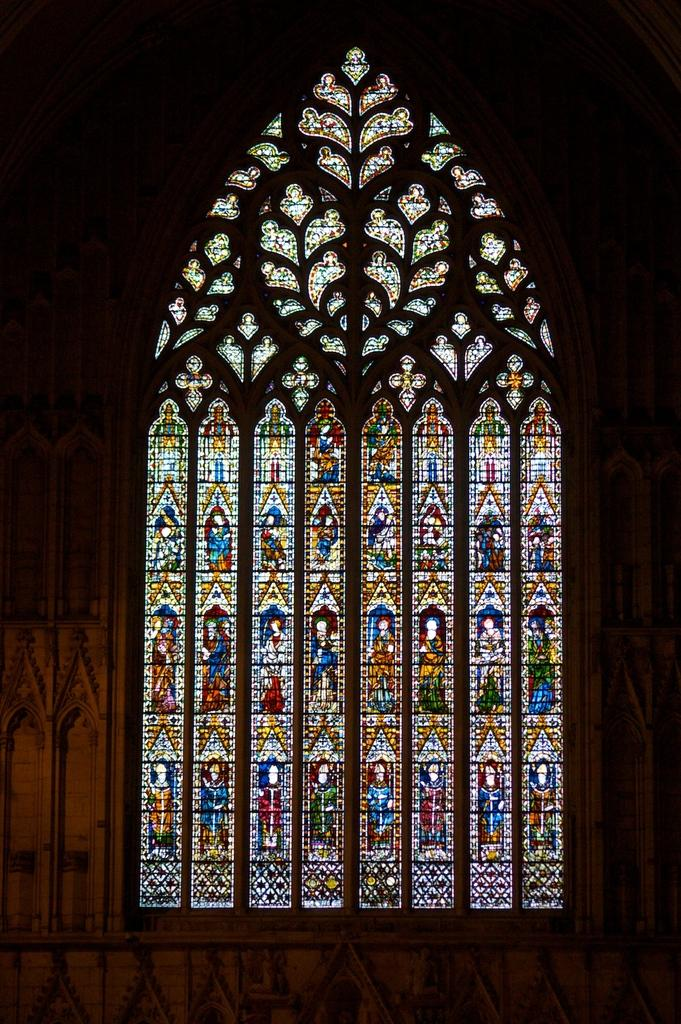What type of artwork is depicted in the image? The image appears to be a stained glass. What is the medium used in this artwork? The medium used in this artwork is stained glass. What colors can be seen in the image? The colors in the image depend on the design of the stained glass, but it typically features vibrant and varied hues. Are there any patches visible on the cobweb in the image? There is no cobweb present in the image, as it is a stained glass artwork. 